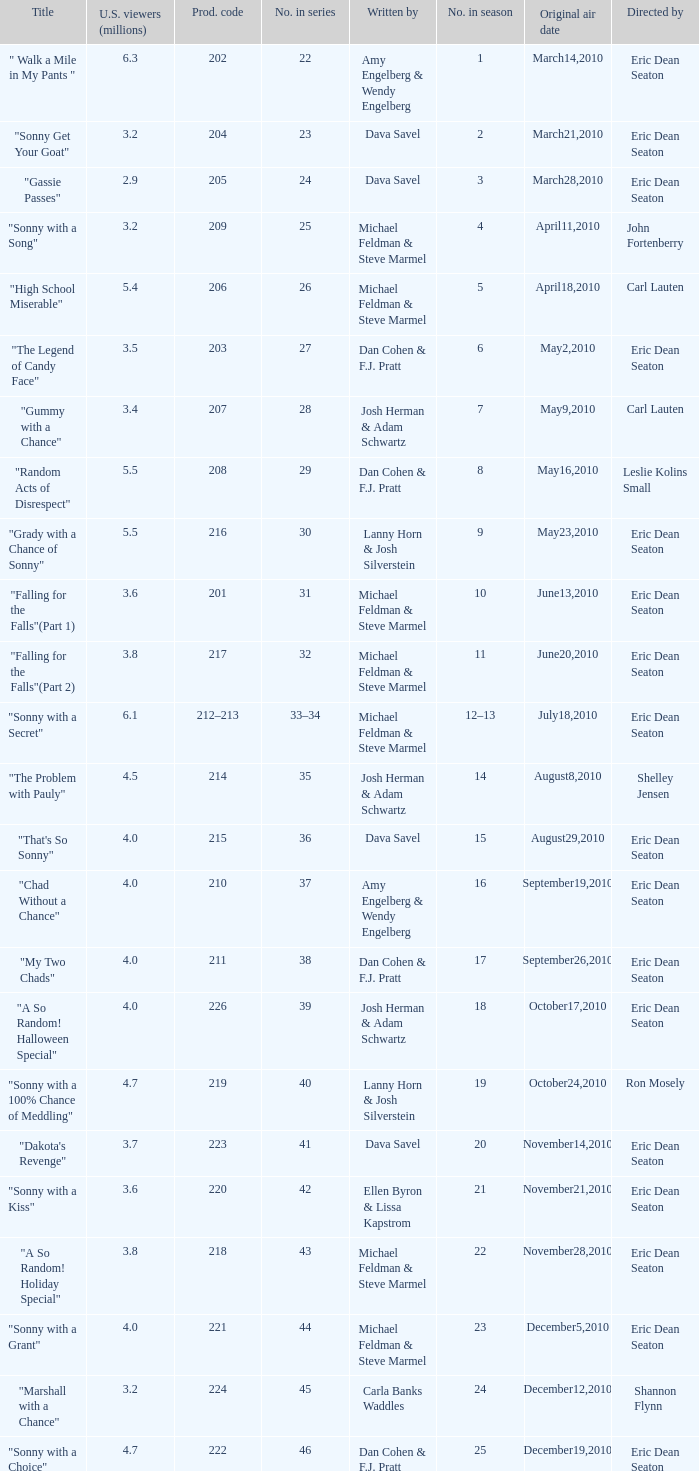Who directed the episode that 6.3 million u.s. viewers saw? Eric Dean Seaton. 